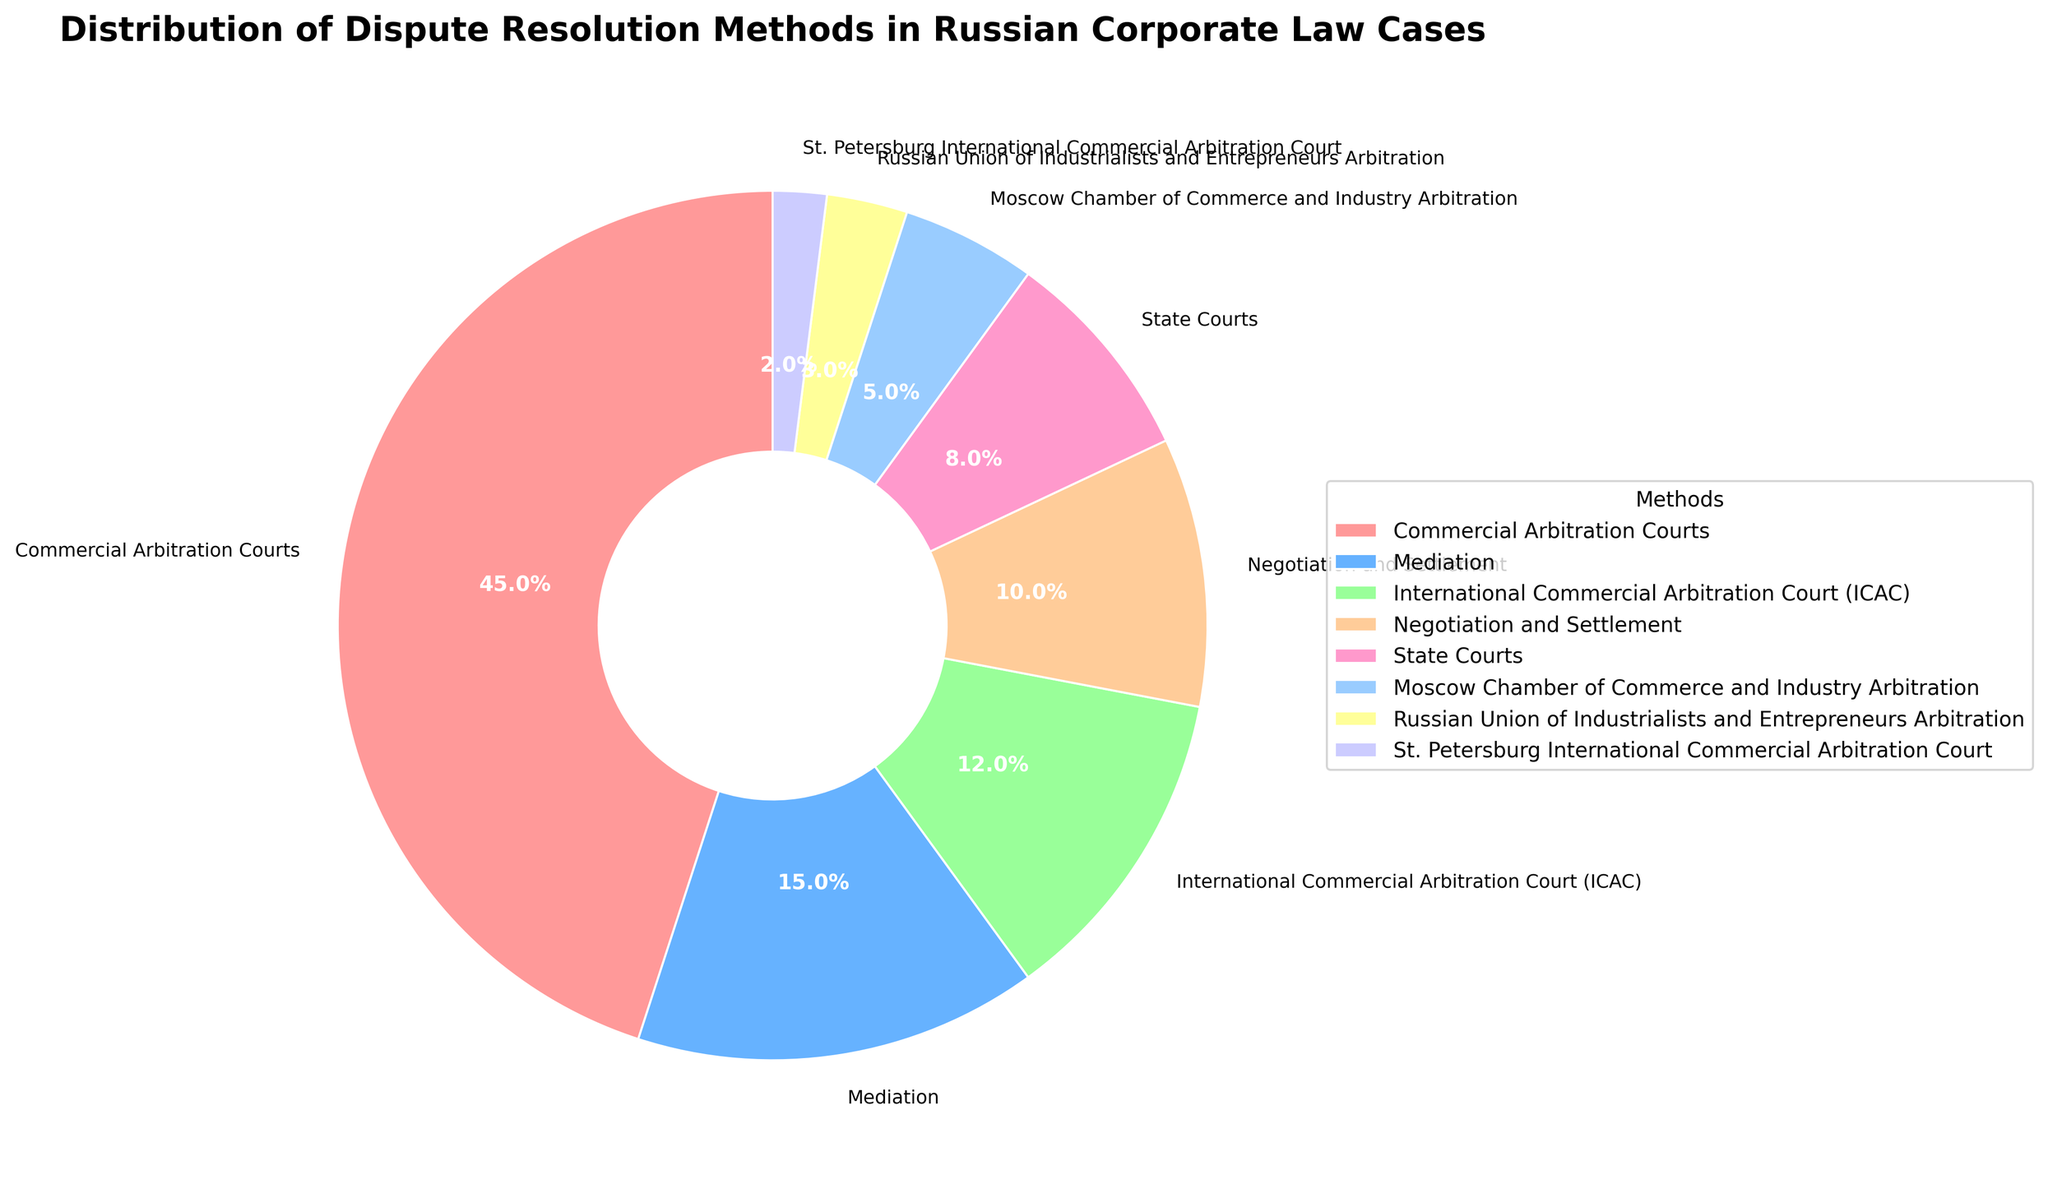Which method accounts for the largest percentage of dispute resolution in Russian corporate law cases? The figure shows that Commercial Arbitration Courts have the largest wedge, which is 45%.
Answer: Commercial Arbitration Courts What percentage of cases are resolved by mediation? The pie chart shows that the wedge representing Mediation has a label of 15%.
Answer: 15% How do the percentages of State Courts and Negotiation and Settlement compare? The pie chart shows that Negotiation and Settlement is at 10% and State Courts are at 8%, meaning Negotiation and Settlement is 2% higher.
Answer: Negotiation and Settlement is 2% higher Which methods collectively account for less than 10% of the dispute resolution methods? Adding up the percentages of Moscow Chamber of Commerce and Industry Arbitration (5%), Russian Union of Industrialists and Entrepreneurs Arbitration (3%), and St. Petersburg International Commercial Arbitration Court (2%) gives a total of 10%, so each of them is individually less than 10%.
Answer: Moscow Chamber of Commerce and Industry Arbitration, Russian Union of Industrialists and Entrepreneurs Arbitration, St. Petersburg International Commercial Arbitration Court What is the percentage difference between Commercial Arbitration Courts and Mediation? From the pie chart, Commercial Arbitration Courts are 45% and Mediation is 15%, the difference is 45% - 15% = 30%.
Answer: 30% Which three methods have the smallest percentages, and what are they? Observing the pie chart, the methods with the smallest percentages are the Russian Union of Industrialists and Entrepreneurs Arbitration (3%), and St. Petersburg International Commercial Arbitration Court (2%).
Answer: Russian Union of Industrialists and Entrepreneurs Arbitration, St. Petersburg International Commercial Arbitration Court How much larger is the percentage for Commercial Arbitration Courts compared to International Commercial Arbitration Court (ICAC)? The pie chart notes Commercial Arbitration Courts at 45% and ICAC at 12%, thus the percentage difference is 45% - 12% = 33%.
Answer: 33% What is the total percentage covered by methods other than Commercial Arbitration Courts? By subtracting the percentage of Commercial Arbitration Courts (45%) from 100%, we get 100% - 45% = 55%.
Answer: 55% If we combine the percentages of Mediation and International Commercial Arbitration Court (ICAC), what is the resulting total? Summing the percentages of Mediation (15%) and ICAC (12%) from the pie chart, we have 15% + 12% = 27%.
Answer: 27% Which method depicted in the pie chart uses a green-colored wedge? The pie chart’s green wedge represents Mediation, labeled as 15%.
Answer: Mediation 